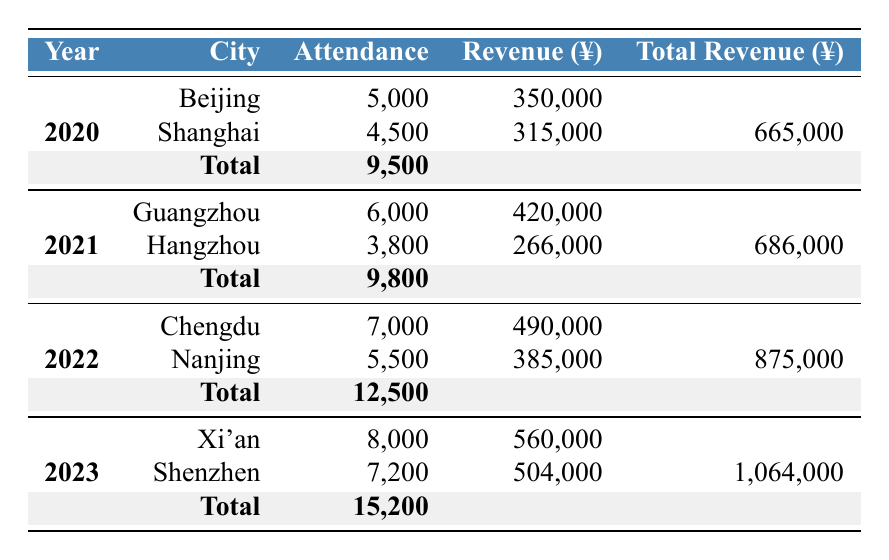What was the total attendance in 2022? The table indicates that in 2022, the total attendance is listed at the bottom of that year's section. It shows 12,500.
Answer: 12,500 How much revenue did Luo Da You generate from the concerts in Shanghai in 2020? The value for revenue from concerts in Shanghai is provided in the table. It states 315,000 for that concert in 2020.
Answer: 315,000 Did Luo Da You perform in Guangzhou in 2020? By checking the table under the 2020 section, it shows concerts held in Beijing and Shanghai only, with no mention of Guangzhou. Therefore, the answer is no.
Answer: No What was the percentage increase in total attendance from 2020 to 2021? The total attendance in 2020 was 9,500 and for 2021, it was 9,800. To calculate the percentage increase: ((9,800 - 9,500) / 9,500) * 100 = 3.16%.
Answer: 3.16% Which year had the highest revenue and what was that revenue? By comparing the total revenue figures from each year, we can see 2023 has the highest total revenue at 1,064,000.
Answer: 1,064,000 How many more attendees were there in 2023 compared to 2021? The total attendance for 2023 is 15,200 and for 2021 it is 9,800. To find the difference: 15,200 - 9,800 = 5,400 attendees more in 2023 than in 2021.
Answer: 5,400 Was there an increase or decrease in attendance from 2021 to 2022? 2021 had a total attendance of 9,800 and 2022 had 12,500. Since 12,500 is greater than 9,800, there was an increase.
Answer: Increase What was the average attendance per concert in 2023? In 2023, there were two concerts in Xi'an and Shenzhen with attendances of 8,000 and 7,200 respectively. Adding those gives 15,200 total attendance over 2 concerts. The average is 15,200 / 2 = 7,600.
Answer: 7,600 In which city was the concert held that generated the lowest revenue in 2021? In 2021, the concert in Hangzhou generated 266,000, while Guangzhou generated 420,000. Therefore, Hangzhou had the lowest revenue for that year.
Answer: Hangzhou 